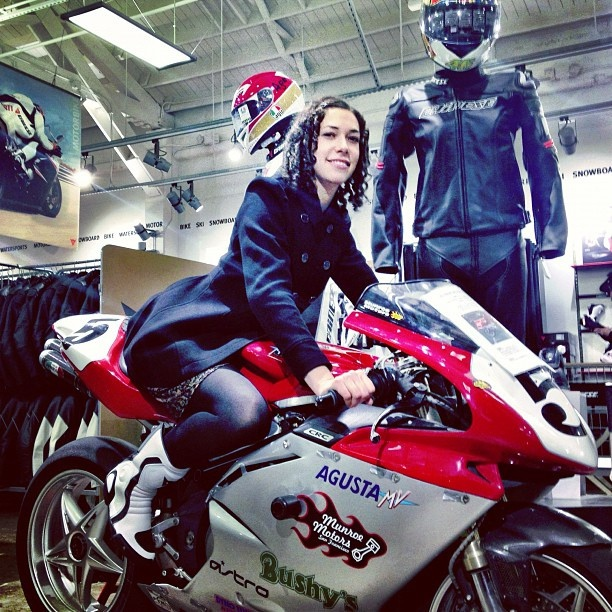Describe the objects in this image and their specific colors. I can see motorcycle in darkgreen, black, darkgray, white, and gray tones, people in darkgreen, black, lightgray, navy, and gray tones, and people in darkgreen, navy, gray, and blue tones in this image. 